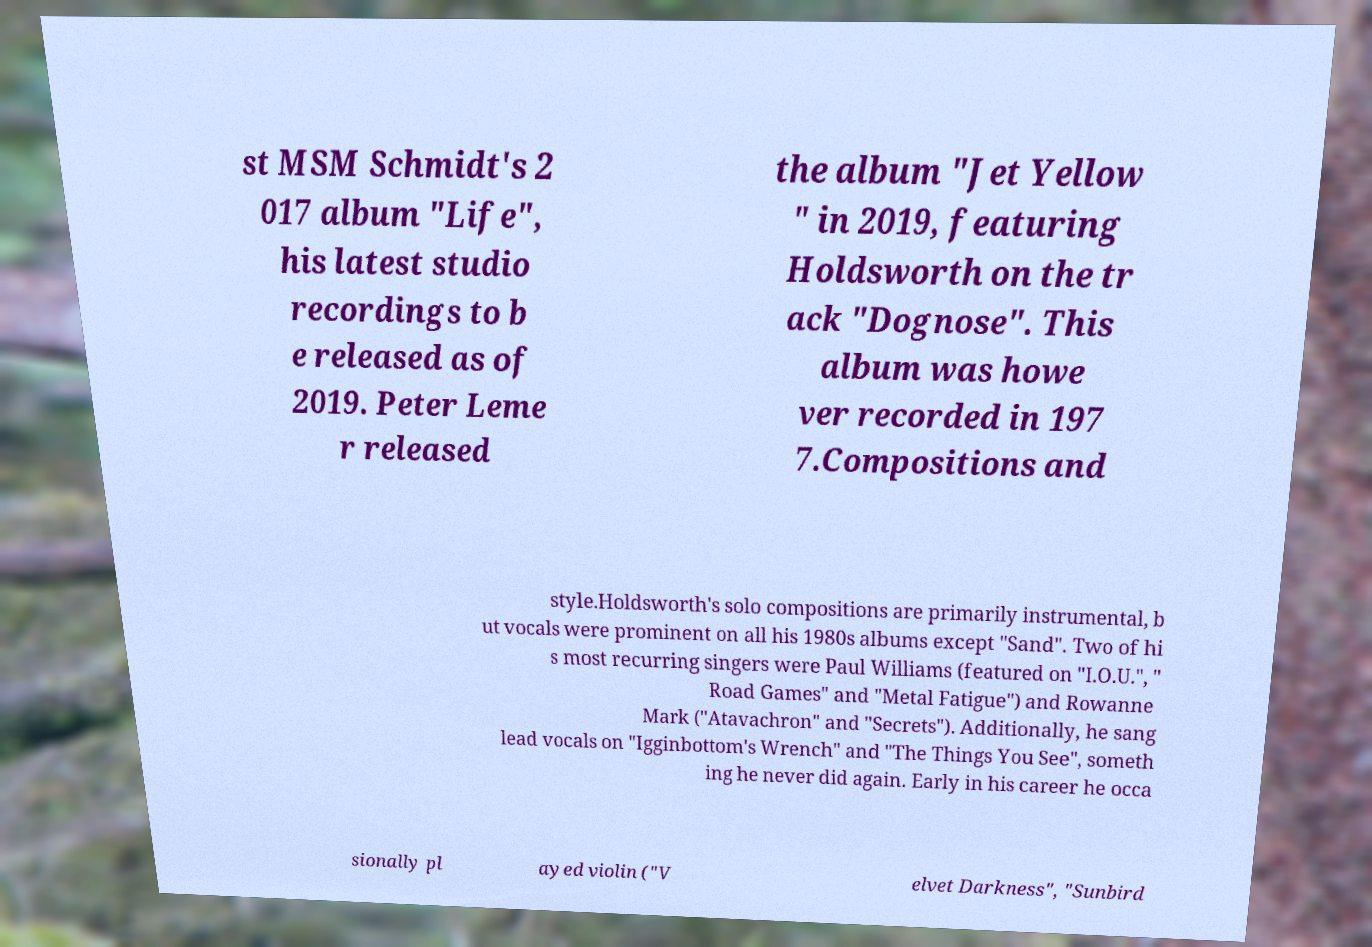I need the written content from this picture converted into text. Can you do that? st MSM Schmidt's 2 017 album "Life", his latest studio recordings to b e released as of 2019. Peter Leme r released the album "Jet Yellow " in 2019, featuring Holdsworth on the tr ack "Dognose". This album was howe ver recorded in 197 7.Compositions and style.Holdsworth's solo compositions are primarily instrumental, b ut vocals were prominent on all his 1980s albums except "Sand". Two of hi s most recurring singers were Paul Williams (featured on "I.O.U.", " Road Games" and "Metal Fatigue") and Rowanne Mark ("Atavachron" and "Secrets"). Additionally, he sang lead vocals on "Igginbottom's Wrench" and "The Things You See", someth ing he never did again. Early in his career he occa sionally pl ayed violin ("V elvet Darkness", "Sunbird 